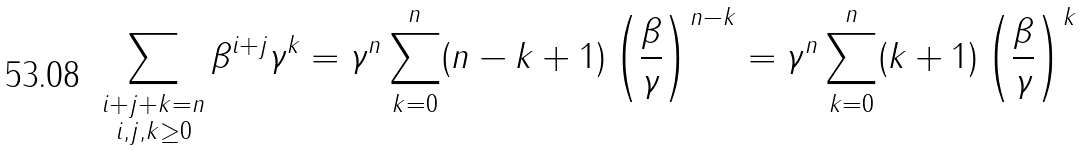<formula> <loc_0><loc_0><loc_500><loc_500>\sum _ { \substack { i + j + k = n \\ i , j , k \geq 0 } } \beta ^ { i + j } \gamma ^ { k } = \gamma ^ { n } \sum _ { k = 0 } ^ { n } ( n - k + 1 ) \left ( \frac { \beta } { \gamma } \right ) ^ { n - k } = \gamma ^ { n } \sum _ { k = 0 } ^ { n } ( k + 1 ) \left ( \frac { \beta } { \gamma } \right ) ^ { k }</formula> 